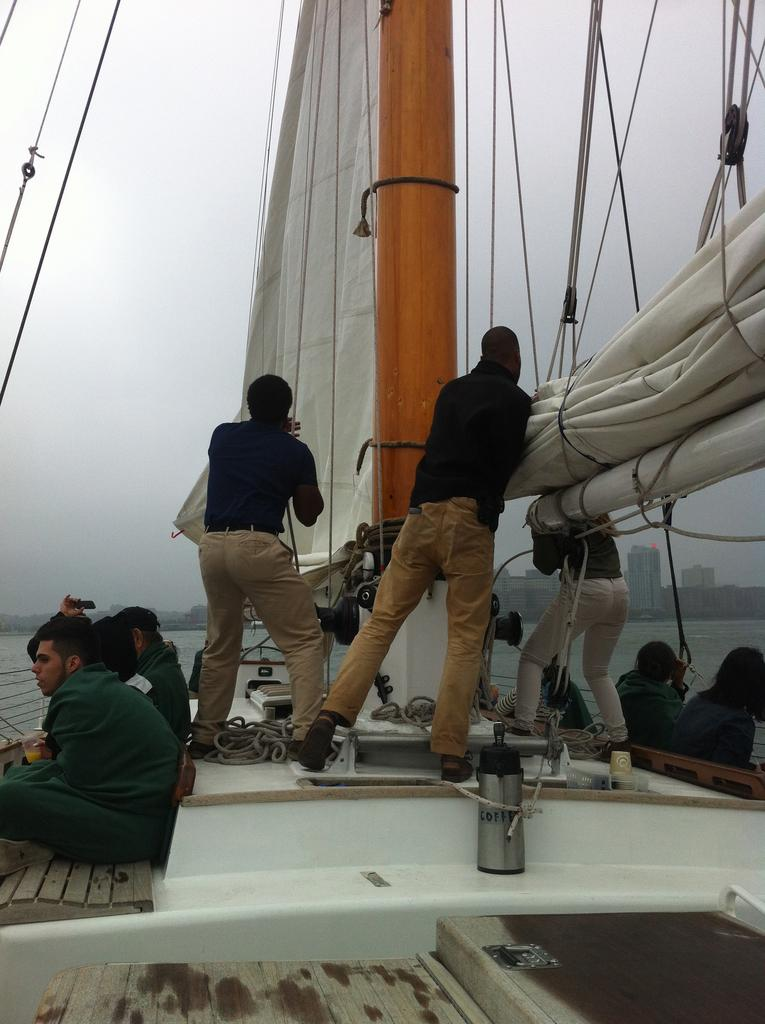What are the people in the image doing? There are persons sitting and standing in the ship. What objects are present in the image related to the ship? Ropes are present in the image. What natural object can be seen in the image? There is a log in the image. What type of material is visible in the image? Cloth is visible in the image. What can be seen in the background of the image? There are buildings in the background of the image. What is the ship floating on in the image? Water is visible in the image. What is visible above the ship in the image? The sky is visible in the image. What type of patch is being used to fix the lunch in the image? There is no patch or lunch present in the image. 